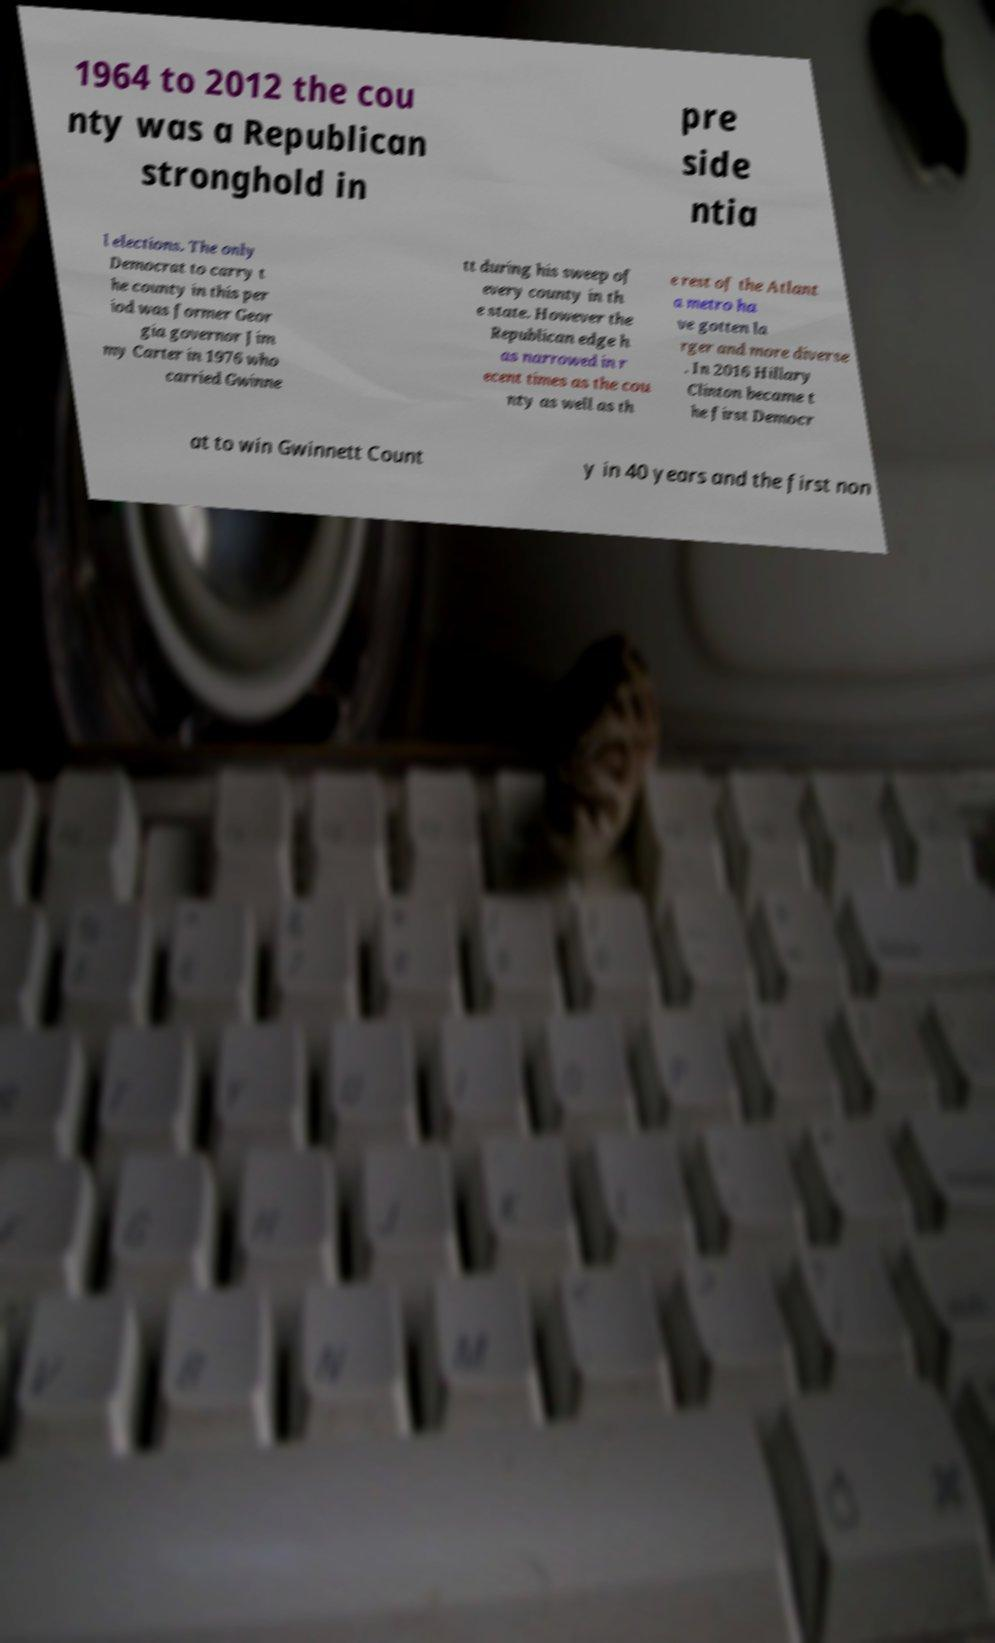Can you read and provide the text displayed in the image?This photo seems to have some interesting text. Can you extract and type it out for me? 1964 to 2012 the cou nty was a Republican stronghold in pre side ntia l elections. The only Democrat to carry t he county in this per iod was former Geor gia governor Jim my Carter in 1976 who carried Gwinne tt during his sweep of every county in th e state. However the Republican edge h as narrowed in r ecent times as the cou nty as well as th e rest of the Atlant a metro ha ve gotten la rger and more diverse . In 2016 Hillary Clinton became t he first Democr at to win Gwinnett Count y in 40 years and the first non 